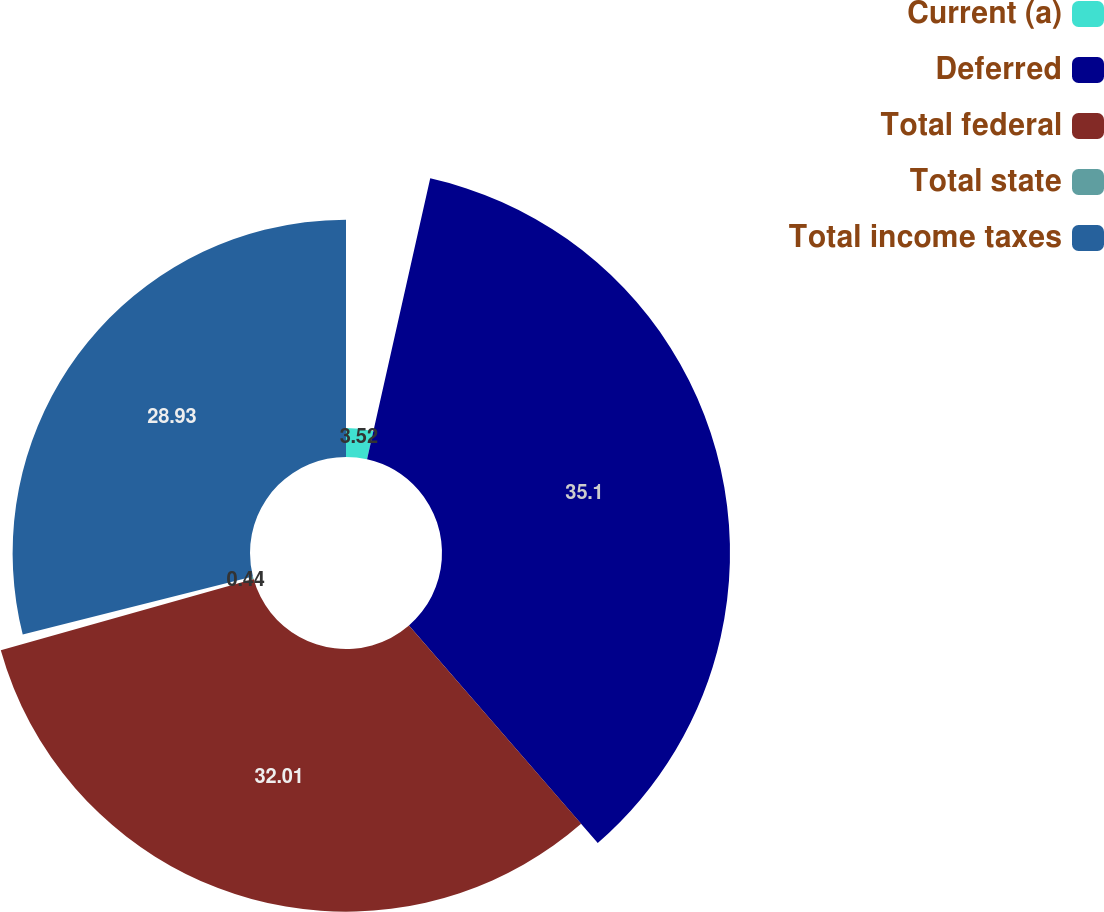Convert chart to OTSL. <chart><loc_0><loc_0><loc_500><loc_500><pie_chart><fcel>Current (a)<fcel>Deferred<fcel>Total federal<fcel>Total state<fcel>Total income taxes<nl><fcel>3.52%<fcel>35.1%<fcel>32.01%<fcel>0.44%<fcel>28.93%<nl></chart> 